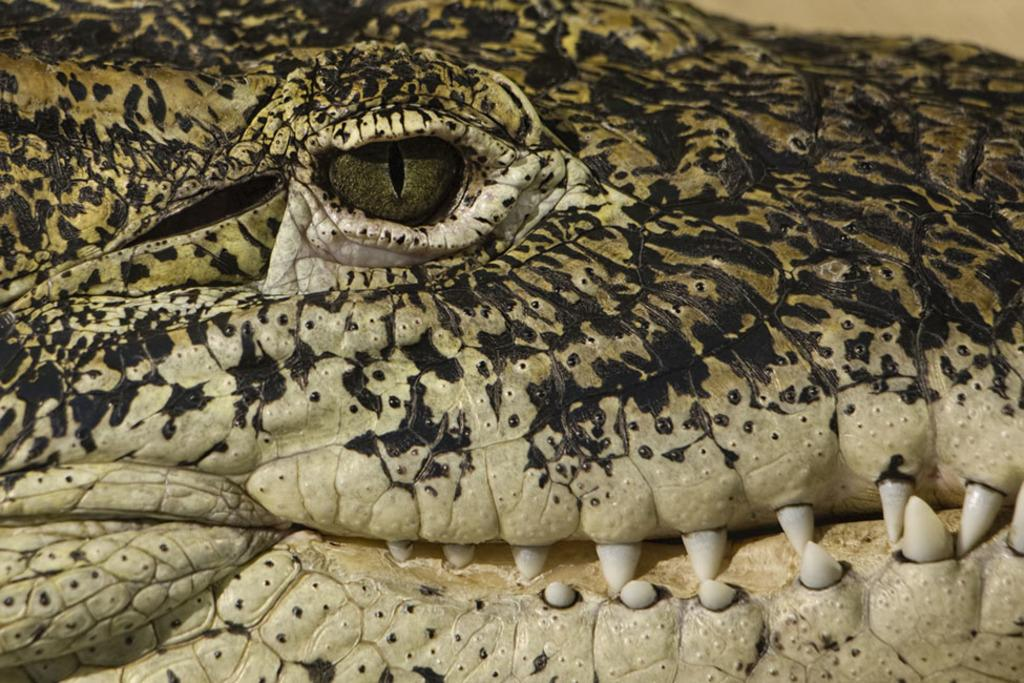What animal is the main subject of the picture? There is a crocodile in the picture. What part of the crocodile can be seen in the image? The crocodile's eye and teeth are visible in the image. What type of surprise can be seen in the crocodile's mouth in the image? There is no surprise visible in the crocodile's mouth in the image; only its teeth are visible. Can you tell me how the crocodile tastes the water while swimming in the image? The image does not show the crocodile swimming or tasting the water; it only shows the crocodile's eye and teeth. 